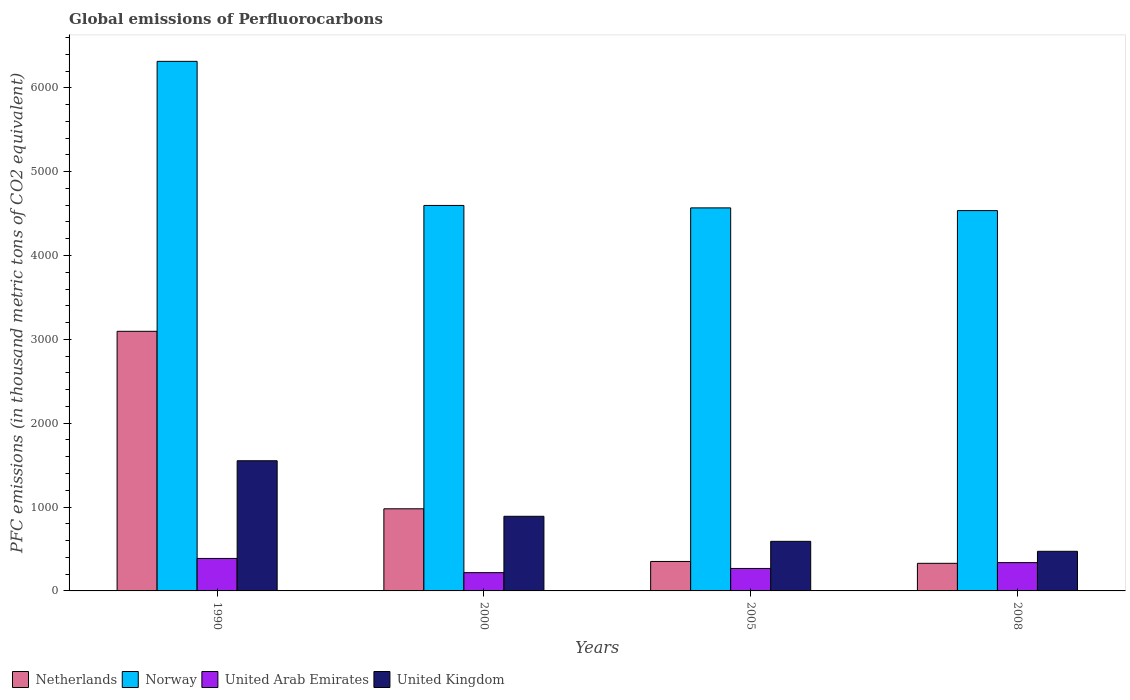How many groups of bars are there?
Offer a very short reply. 4. Are the number of bars on each tick of the X-axis equal?
Offer a very short reply. Yes. In how many cases, is the number of bars for a given year not equal to the number of legend labels?
Your answer should be compact. 0. What is the global emissions of Perfluorocarbons in United Kingdom in 1990?
Your answer should be very brief. 1552.5. Across all years, what is the maximum global emissions of Perfluorocarbons in Netherlands?
Offer a terse response. 3096.2. Across all years, what is the minimum global emissions of Perfluorocarbons in United Arab Emirates?
Offer a very short reply. 218. In which year was the global emissions of Perfluorocarbons in United Kingdom maximum?
Give a very brief answer. 1990. What is the total global emissions of Perfluorocarbons in United Arab Emirates in the graph?
Your answer should be compact. 1210.8. What is the difference between the global emissions of Perfluorocarbons in Netherlands in 2005 and that in 2008?
Offer a very short reply. 22.2. What is the difference between the global emissions of Perfluorocarbons in Netherlands in 2008 and the global emissions of Perfluorocarbons in United Arab Emirates in 1990?
Offer a terse response. -58.1. What is the average global emissions of Perfluorocarbons in United Kingdom per year?
Your answer should be very brief. 876.6. In the year 2008, what is the difference between the global emissions of Perfluorocarbons in United Kingdom and global emissions of Perfluorocarbons in United Arab Emirates?
Offer a terse response. 134.8. What is the ratio of the global emissions of Perfluorocarbons in Norway in 1990 to that in 2008?
Provide a succinct answer. 1.39. Is the difference between the global emissions of Perfluorocarbons in United Kingdom in 2000 and 2005 greater than the difference between the global emissions of Perfluorocarbons in United Arab Emirates in 2000 and 2005?
Your answer should be very brief. Yes. What is the difference between the highest and the second highest global emissions of Perfluorocarbons in United Arab Emirates?
Your answer should be very brief. 49.7. What is the difference between the highest and the lowest global emissions of Perfluorocarbons in Netherlands?
Ensure brevity in your answer.  2767. In how many years, is the global emissions of Perfluorocarbons in United Arab Emirates greater than the average global emissions of Perfluorocarbons in United Arab Emirates taken over all years?
Ensure brevity in your answer.  2. Is it the case that in every year, the sum of the global emissions of Perfluorocarbons in United Arab Emirates and global emissions of Perfluorocarbons in Netherlands is greater than the sum of global emissions of Perfluorocarbons in Norway and global emissions of Perfluorocarbons in United Kingdom?
Your response must be concise. Yes. What does the 4th bar from the left in 1990 represents?
Your answer should be compact. United Kingdom. Is it the case that in every year, the sum of the global emissions of Perfluorocarbons in United Arab Emirates and global emissions of Perfluorocarbons in Netherlands is greater than the global emissions of Perfluorocarbons in United Kingdom?
Provide a succinct answer. Yes. How many bars are there?
Your answer should be compact. 16. Are all the bars in the graph horizontal?
Offer a very short reply. No. How many years are there in the graph?
Provide a succinct answer. 4. Are the values on the major ticks of Y-axis written in scientific E-notation?
Ensure brevity in your answer.  No. What is the title of the graph?
Offer a very short reply. Global emissions of Perfluorocarbons. What is the label or title of the Y-axis?
Give a very brief answer. PFC emissions (in thousand metric tons of CO2 equivalent). What is the PFC emissions (in thousand metric tons of CO2 equivalent) in Netherlands in 1990?
Your response must be concise. 3096.2. What is the PFC emissions (in thousand metric tons of CO2 equivalent) in Norway in 1990?
Offer a very short reply. 6315.7. What is the PFC emissions (in thousand metric tons of CO2 equivalent) of United Arab Emirates in 1990?
Provide a short and direct response. 387.3. What is the PFC emissions (in thousand metric tons of CO2 equivalent) in United Kingdom in 1990?
Offer a terse response. 1552.5. What is the PFC emissions (in thousand metric tons of CO2 equivalent) of Netherlands in 2000?
Your response must be concise. 979.5. What is the PFC emissions (in thousand metric tons of CO2 equivalent) in Norway in 2000?
Ensure brevity in your answer.  4597.3. What is the PFC emissions (in thousand metric tons of CO2 equivalent) in United Arab Emirates in 2000?
Offer a terse response. 218. What is the PFC emissions (in thousand metric tons of CO2 equivalent) in United Kingdom in 2000?
Your answer should be compact. 890.1. What is the PFC emissions (in thousand metric tons of CO2 equivalent) in Netherlands in 2005?
Your answer should be very brief. 351.4. What is the PFC emissions (in thousand metric tons of CO2 equivalent) of Norway in 2005?
Offer a very short reply. 4568.1. What is the PFC emissions (in thousand metric tons of CO2 equivalent) in United Arab Emirates in 2005?
Provide a succinct answer. 267.9. What is the PFC emissions (in thousand metric tons of CO2 equivalent) in United Kingdom in 2005?
Provide a short and direct response. 591.4. What is the PFC emissions (in thousand metric tons of CO2 equivalent) of Netherlands in 2008?
Provide a succinct answer. 329.2. What is the PFC emissions (in thousand metric tons of CO2 equivalent) of Norway in 2008?
Provide a short and direct response. 4535.7. What is the PFC emissions (in thousand metric tons of CO2 equivalent) of United Arab Emirates in 2008?
Provide a succinct answer. 337.6. What is the PFC emissions (in thousand metric tons of CO2 equivalent) of United Kingdom in 2008?
Keep it short and to the point. 472.4. Across all years, what is the maximum PFC emissions (in thousand metric tons of CO2 equivalent) in Netherlands?
Offer a terse response. 3096.2. Across all years, what is the maximum PFC emissions (in thousand metric tons of CO2 equivalent) of Norway?
Your answer should be very brief. 6315.7. Across all years, what is the maximum PFC emissions (in thousand metric tons of CO2 equivalent) of United Arab Emirates?
Your response must be concise. 387.3. Across all years, what is the maximum PFC emissions (in thousand metric tons of CO2 equivalent) of United Kingdom?
Provide a short and direct response. 1552.5. Across all years, what is the minimum PFC emissions (in thousand metric tons of CO2 equivalent) of Netherlands?
Keep it short and to the point. 329.2. Across all years, what is the minimum PFC emissions (in thousand metric tons of CO2 equivalent) of Norway?
Make the answer very short. 4535.7. Across all years, what is the minimum PFC emissions (in thousand metric tons of CO2 equivalent) of United Arab Emirates?
Your answer should be compact. 218. Across all years, what is the minimum PFC emissions (in thousand metric tons of CO2 equivalent) in United Kingdom?
Offer a terse response. 472.4. What is the total PFC emissions (in thousand metric tons of CO2 equivalent) of Netherlands in the graph?
Provide a short and direct response. 4756.3. What is the total PFC emissions (in thousand metric tons of CO2 equivalent) of Norway in the graph?
Give a very brief answer. 2.00e+04. What is the total PFC emissions (in thousand metric tons of CO2 equivalent) in United Arab Emirates in the graph?
Offer a very short reply. 1210.8. What is the total PFC emissions (in thousand metric tons of CO2 equivalent) in United Kingdom in the graph?
Offer a very short reply. 3506.4. What is the difference between the PFC emissions (in thousand metric tons of CO2 equivalent) in Netherlands in 1990 and that in 2000?
Provide a succinct answer. 2116.7. What is the difference between the PFC emissions (in thousand metric tons of CO2 equivalent) of Norway in 1990 and that in 2000?
Keep it short and to the point. 1718.4. What is the difference between the PFC emissions (in thousand metric tons of CO2 equivalent) of United Arab Emirates in 1990 and that in 2000?
Your answer should be very brief. 169.3. What is the difference between the PFC emissions (in thousand metric tons of CO2 equivalent) in United Kingdom in 1990 and that in 2000?
Keep it short and to the point. 662.4. What is the difference between the PFC emissions (in thousand metric tons of CO2 equivalent) in Netherlands in 1990 and that in 2005?
Offer a terse response. 2744.8. What is the difference between the PFC emissions (in thousand metric tons of CO2 equivalent) of Norway in 1990 and that in 2005?
Provide a succinct answer. 1747.6. What is the difference between the PFC emissions (in thousand metric tons of CO2 equivalent) of United Arab Emirates in 1990 and that in 2005?
Keep it short and to the point. 119.4. What is the difference between the PFC emissions (in thousand metric tons of CO2 equivalent) of United Kingdom in 1990 and that in 2005?
Give a very brief answer. 961.1. What is the difference between the PFC emissions (in thousand metric tons of CO2 equivalent) in Netherlands in 1990 and that in 2008?
Ensure brevity in your answer.  2767. What is the difference between the PFC emissions (in thousand metric tons of CO2 equivalent) of Norway in 1990 and that in 2008?
Offer a terse response. 1780. What is the difference between the PFC emissions (in thousand metric tons of CO2 equivalent) in United Arab Emirates in 1990 and that in 2008?
Your answer should be very brief. 49.7. What is the difference between the PFC emissions (in thousand metric tons of CO2 equivalent) of United Kingdom in 1990 and that in 2008?
Your response must be concise. 1080.1. What is the difference between the PFC emissions (in thousand metric tons of CO2 equivalent) in Netherlands in 2000 and that in 2005?
Offer a terse response. 628.1. What is the difference between the PFC emissions (in thousand metric tons of CO2 equivalent) of Norway in 2000 and that in 2005?
Ensure brevity in your answer.  29.2. What is the difference between the PFC emissions (in thousand metric tons of CO2 equivalent) of United Arab Emirates in 2000 and that in 2005?
Provide a short and direct response. -49.9. What is the difference between the PFC emissions (in thousand metric tons of CO2 equivalent) in United Kingdom in 2000 and that in 2005?
Offer a terse response. 298.7. What is the difference between the PFC emissions (in thousand metric tons of CO2 equivalent) in Netherlands in 2000 and that in 2008?
Make the answer very short. 650.3. What is the difference between the PFC emissions (in thousand metric tons of CO2 equivalent) in Norway in 2000 and that in 2008?
Your answer should be compact. 61.6. What is the difference between the PFC emissions (in thousand metric tons of CO2 equivalent) in United Arab Emirates in 2000 and that in 2008?
Your response must be concise. -119.6. What is the difference between the PFC emissions (in thousand metric tons of CO2 equivalent) in United Kingdom in 2000 and that in 2008?
Offer a terse response. 417.7. What is the difference between the PFC emissions (in thousand metric tons of CO2 equivalent) in Netherlands in 2005 and that in 2008?
Provide a succinct answer. 22.2. What is the difference between the PFC emissions (in thousand metric tons of CO2 equivalent) in Norway in 2005 and that in 2008?
Ensure brevity in your answer.  32.4. What is the difference between the PFC emissions (in thousand metric tons of CO2 equivalent) in United Arab Emirates in 2005 and that in 2008?
Provide a short and direct response. -69.7. What is the difference between the PFC emissions (in thousand metric tons of CO2 equivalent) in United Kingdom in 2005 and that in 2008?
Keep it short and to the point. 119. What is the difference between the PFC emissions (in thousand metric tons of CO2 equivalent) in Netherlands in 1990 and the PFC emissions (in thousand metric tons of CO2 equivalent) in Norway in 2000?
Your answer should be compact. -1501.1. What is the difference between the PFC emissions (in thousand metric tons of CO2 equivalent) in Netherlands in 1990 and the PFC emissions (in thousand metric tons of CO2 equivalent) in United Arab Emirates in 2000?
Offer a terse response. 2878.2. What is the difference between the PFC emissions (in thousand metric tons of CO2 equivalent) in Netherlands in 1990 and the PFC emissions (in thousand metric tons of CO2 equivalent) in United Kingdom in 2000?
Make the answer very short. 2206.1. What is the difference between the PFC emissions (in thousand metric tons of CO2 equivalent) in Norway in 1990 and the PFC emissions (in thousand metric tons of CO2 equivalent) in United Arab Emirates in 2000?
Your response must be concise. 6097.7. What is the difference between the PFC emissions (in thousand metric tons of CO2 equivalent) in Norway in 1990 and the PFC emissions (in thousand metric tons of CO2 equivalent) in United Kingdom in 2000?
Your response must be concise. 5425.6. What is the difference between the PFC emissions (in thousand metric tons of CO2 equivalent) in United Arab Emirates in 1990 and the PFC emissions (in thousand metric tons of CO2 equivalent) in United Kingdom in 2000?
Provide a succinct answer. -502.8. What is the difference between the PFC emissions (in thousand metric tons of CO2 equivalent) of Netherlands in 1990 and the PFC emissions (in thousand metric tons of CO2 equivalent) of Norway in 2005?
Give a very brief answer. -1471.9. What is the difference between the PFC emissions (in thousand metric tons of CO2 equivalent) in Netherlands in 1990 and the PFC emissions (in thousand metric tons of CO2 equivalent) in United Arab Emirates in 2005?
Your answer should be very brief. 2828.3. What is the difference between the PFC emissions (in thousand metric tons of CO2 equivalent) in Netherlands in 1990 and the PFC emissions (in thousand metric tons of CO2 equivalent) in United Kingdom in 2005?
Your response must be concise. 2504.8. What is the difference between the PFC emissions (in thousand metric tons of CO2 equivalent) in Norway in 1990 and the PFC emissions (in thousand metric tons of CO2 equivalent) in United Arab Emirates in 2005?
Ensure brevity in your answer.  6047.8. What is the difference between the PFC emissions (in thousand metric tons of CO2 equivalent) of Norway in 1990 and the PFC emissions (in thousand metric tons of CO2 equivalent) of United Kingdom in 2005?
Your answer should be compact. 5724.3. What is the difference between the PFC emissions (in thousand metric tons of CO2 equivalent) of United Arab Emirates in 1990 and the PFC emissions (in thousand metric tons of CO2 equivalent) of United Kingdom in 2005?
Your answer should be compact. -204.1. What is the difference between the PFC emissions (in thousand metric tons of CO2 equivalent) in Netherlands in 1990 and the PFC emissions (in thousand metric tons of CO2 equivalent) in Norway in 2008?
Your answer should be very brief. -1439.5. What is the difference between the PFC emissions (in thousand metric tons of CO2 equivalent) of Netherlands in 1990 and the PFC emissions (in thousand metric tons of CO2 equivalent) of United Arab Emirates in 2008?
Offer a very short reply. 2758.6. What is the difference between the PFC emissions (in thousand metric tons of CO2 equivalent) in Netherlands in 1990 and the PFC emissions (in thousand metric tons of CO2 equivalent) in United Kingdom in 2008?
Provide a short and direct response. 2623.8. What is the difference between the PFC emissions (in thousand metric tons of CO2 equivalent) of Norway in 1990 and the PFC emissions (in thousand metric tons of CO2 equivalent) of United Arab Emirates in 2008?
Offer a terse response. 5978.1. What is the difference between the PFC emissions (in thousand metric tons of CO2 equivalent) of Norway in 1990 and the PFC emissions (in thousand metric tons of CO2 equivalent) of United Kingdom in 2008?
Give a very brief answer. 5843.3. What is the difference between the PFC emissions (in thousand metric tons of CO2 equivalent) of United Arab Emirates in 1990 and the PFC emissions (in thousand metric tons of CO2 equivalent) of United Kingdom in 2008?
Offer a very short reply. -85.1. What is the difference between the PFC emissions (in thousand metric tons of CO2 equivalent) in Netherlands in 2000 and the PFC emissions (in thousand metric tons of CO2 equivalent) in Norway in 2005?
Provide a short and direct response. -3588.6. What is the difference between the PFC emissions (in thousand metric tons of CO2 equivalent) in Netherlands in 2000 and the PFC emissions (in thousand metric tons of CO2 equivalent) in United Arab Emirates in 2005?
Provide a short and direct response. 711.6. What is the difference between the PFC emissions (in thousand metric tons of CO2 equivalent) of Netherlands in 2000 and the PFC emissions (in thousand metric tons of CO2 equivalent) of United Kingdom in 2005?
Your answer should be compact. 388.1. What is the difference between the PFC emissions (in thousand metric tons of CO2 equivalent) in Norway in 2000 and the PFC emissions (in thousand metric tons of CO2 equivalent) in United Arab Emirates in 2005?
Offer a terse response. 4329.4. What is the difference between the PFC emissions (in thousand metric tons of CO2 equivalent) in Norway in 2000 and the PFC emissions (in thousand metric tons of CO2 equivalent) in United Kingdom in 2005?
Provide a short and direct response. 4005.9. What is the difference between the PFC emissions (in thousand metric tons of CO2 equivalent) of United Arab Emirates in 2000 and the PFC emissions (in thousand metric tons of CO2 equivalent) of United Kingdom in 2005?
Your response must be concise. -373.4. What is the difference between the PFC emissions (in thousand metric tons of CO2 equivalent) in Netherlands in 2000 and the PFC emissions (in thousand metric tons of CO2 equivalent) in Norway in 2008?
Keep it short and to the point. -3556.2. What is the difference between the PFC emissions (in thousand metric tons of CO2 equivalent) in Netherlands in 2000 and the PFC emissions (in thousand metric tons of CO2 equivalent) in United Arab Emirates in 2008?
Your answer should be compact. 641.9. What is the difference between the PFC emissions (in thousand metric tons of CO2 equivalent) of Netherlands in 2000 and the PFC emissions (in thousand metric tons of CO2 equivalent) of United Kingdom in 2008?
Provide a short and direct response. 507.1. What is the difference between the PFC emissions (in thousand metric tons of CO2 equivalent) in Norway in 2000 and the PFC emissions (in thousand metric tons of CO2 equivalent) in United Arab Emirates in 2008?
Keep it short and to the point. 4259.7. What is the difference between the PFC emissions (in thousand metric tons of CO2 equivalent) of Norway in 2000 and the PFC emissions (in thousand metric tons of CO2 equivalent) of United Kingdom in 2008?
Give a very brief answer. 4124.9. What is the difference between the PFC emissions (in thousand metric tons of CO2 equivalent) in United Arab Emirates in 2000 and the PFC emissions (in thousand metric tons of CO2 equivalent) in United Kingdom in 2008?
Offer a terse response. -254.4. What is the difference between the PFC emissions (in thousand metric tons of CO2 equivalent) in Netherlands in 2005 and the PFC emissions (in thousand metric tons of CO2 equivalent) in Norway in 2008?
Provide a short and direct response. -4184.3. What is the difference between the PFC emissions (in thousand metric tons of CO2 equivalent) in Netherlands in 2005 and the PFC emissions (in thousand metric tons of CO2 equivalent) in United Kingdom in 2008?
Provide a short and direct response. -121. What is the difference between the PFC emissions (in thousand metric tons of CO2 equivalent) in Norway in 2005 and the PFC emissions (in thousand metric tons of CO2 equivalent) in United Arab Emirates in 2008?
Your answer should be compact. 4230.5. What is the difference between the PFC emissions (in thousand metric tons of CO2 equivalent) in Norway in 2005 and the PFC emissions (in thousand metric tons of CO2 equivalent) in United Kingdom in 2008?
Ensure brevity in your answer.  4095.7. What is the difference between the PFC emissions (in thousand metric tons of CO2 equivalent) of United Arab Emirates in 2005 and the PFC emissions (in thousand metric tons of CO2 equivalent) of United Kingdom in 2008?
Provide a short and direct response. -204.5. What is the average PFC emissions (in thousand metric tons of CO2 equivalent) of Netherlands per year?
Give a very brief answer. 1189.08. What is the average PFC emissions (in thousand metric tons of CO2 equivalent) in Norway per year?
Ensure brevity in your answer.  5004.2. What is the average PFC emissions (in thousand metric tons of CO2 equivalent) of United Arab Emirates per year?
Provide a succinct answer. 302.7. What is the average PFC emissions (in thousand metric tons of CO2 equivalent) of United Kingdom per year?
Keep it short and to the point. 876.6. In the year 1990, what is the difference between the PFC emissions (in thousand metric tons of CO2 equivalent) in Netherlands and PFC emissions (in thousand metric tons of CO2 equivalent) in Norway?
Keep it short and to the point. -3219.5. In the year 1990, what is the difference between the PFC emissions (in thousand metric tons of CO2 equivalent) in Netherlands and PFC emissions (in thousand metric tons of CO2 equivalent) in United Arab Emirates?
Offer a very short reply. 2708.9. In the year 1990, what is the difference between the PFC emissions (in thousand metric tons of CO2 equivalent) of Netherlands and PFC emissions (in thousand metric tons of CO2 equivalent) of United Kingdom?
Make the answer very short. 1543.7. In the year 1990, what is the difference between the PFC emissions (in thousand metric tons of CO2 equivalent) of Norway and PFC emissions (in thousand metric tons of CO2 equivalent) of United Arab Emirates?
Offer a terse response. 5928.4. In the year 1990, what is the difference between the PFC emissions (in thousand metric tons of CO2 equivalent) of Norway and PFC emissions (in thousand metric tons of CO2 equivalent) of United Kingdom?
Your answer should be very brief. 4763.2. In the year 1990, what is the difference between the PFC emissions (in thousand metric tons of CO2 equivalent) in United Arab Emirates and PFC emissions (in thousand metric tons of CO2 equivalent) in United Kingdom?
Offer a very short reply. -1165.2. In the year 2000, what is the difference between the PFC emissions (in thousand metric tons of CO2 equivalent) of Netherlands and PFC emissions (in thousand metric tons of CO2 equivalent) of Norway?
Offer a terse response. -3617.8. In the year 2000, what is the difference between the PFC emissions (in thousand metric tons of CO2 equivalent) in Netherlands and PFC emissions (in thousand metric tons of CO2 equivalent) in United Arab Emirates?
Make the answer very short. 761.5. In the year 2000, what is the difference between the PFC emissions (in thousand metric tons of CO2 equivalent) in Netherlands and PFC emissions (in thousand metric tons of CO2 equivalent) in United Kingdom?
Offer a very short reply. 89.4. In the year 2000, what is the difference between the PFC emissions (in thousand metric tons of CO2 equivalent) in Norway and PFC emissions (in thousand metric tons of CO2 equivalent) in United Arab Emirates?
Provide a short and direct response. 4379.3. In the year 2000, what is the difference between the PFC emissions (in thousand metric tons of CO2 equivalent) in Norway and PFC emissions (in thousand metric tons of CO2 equivalent) in United Kingdom?
Ensure brevity in your answer.  3707.2. In the year 2000, what is the difference between the PFC emissions (in thousand metric tons of CO2 equivalent) in United Arab Emirates and PFC emissions (in thousand metric tons of CO2 equivalent) in United Kingdom?
Ensure brevity in your answer.  -672.1. In the year 2005, what is the difference between the PFC emissions (in thousand metric tons of CO2 equivalent) of Netherlands and PFC emissions (in thousand metric tons of CO2 equivalent) of Norway?
Provide a succinct answer. -4216.7. In the year 2005, what is the difference between the PFC emissions (in thousand metric tons of CO2 equivalent) in Netherlands and PFC emissions (in thousand metric tons of CO2 equivalent) in United Arab Emirates?
Your response must be concise. 83.5. In the year 2005, what is the difference between the PFC emissions (in thousand metric tons of CO2 equivalent) of Netherlands and PFC emissions (in thousand metric tons of CO2 equivalent) of United Kingdom?
Give a very brief answer. -240. In the year 2005, what is the difference between the PFC emissions (in thousand metric tons of CO2 equivalent) in Norway and PFC emissions (in thousand metric tons of CO2 equivalent) in United Arab Emirates?
Your answer should be compact. 4300.2. In the year 2005, what is the difference between the PFC emissions (in thousand metric tons of CO2 equivalent) in Norway and PFC emissions (in thousand metric tons of CO2 equivalent) in United Kingdom?
Offer a very short reply. 3976.7. In the year 2005, what is the difference between the PFC emissions (in thousand metric tons of CO2 equivalent) of United Arab Emirates and PFC emissions (in thousand metric tons of CO2 equivalent) of United Kingdom?
Make the answer very short. -323.5. In the year 2008, what is the difference between the PFC emissions (in thousand metric tons of CO2 equivalent) in Netherlands and PFC emissions (in thousand metric tons of CO2 equivalent) in Norway?
Offer a very short reply. -4206.5. In the year 2008, what is the difference between the PFC emissions (in thousand metric tons of CO2 equivalent) of Netherlands and PFC emissions (in thousand metric tons of CO2 equivalent) of United Kingdom?
Make the answer very short. -143.2. In the year 2008, what is the difference between the PFC emissions (in thousand metric tons of CO2 equivalent) of Norway and PFC emissions (in thousand metric tons of CO2 equivalent) of United Arab Emirates?
Keep it short and to the point. 4198.1. In the year 2008, what is the difference between the PFC emissions (in thousand metric tons of CO2 equivalent) in Norway and PFC emissions (in thousand metric tons of CO2 equivalent) in United Kingdom?
Give a very brief answer. 4063.3. In the year 2008, what is the difference between the PFC emissions (in thousand metric tons of CO2 equivalent) of United Arab Emirates and PFC emissions (in thousand metric tons of CO2 equivalent) of United Kingdom?
Your response must be concise. -134.8. What is the ratio of the PFC emissions (in thousand metric tons of CO2 equivalent) in Netherlands in 1990 to that in 2000?
Provide a succinct answer. 3.16. What is the ratio of the PFC emissions (in thousand metric tons of CO2 equivalent) of Norway in 1990 to that in 2000?
Offer a terse response. 1.37. What is the ratio of the PFC emissions (in thousand metric tons of CO2 equivalent) in United Arab Emirates in 1990 to that in 2000?
Your answer should be compact. 1.78. What is the ratio of the PFC emissions (in thousand metric tons of CO2 equivalent) of United Kingdom in 1990 to that in 2000?
Make the answer very short. 1.74. What is the ratio of the PFC emissions (in thousand metric tons of CO2 equivalent) of Netherlands in 1990 to that in 2005?
Provide a short and direct response. 8.81. What is the ratio of the PFC emissions (in thousand metric tons of CO2 equivalent) of Norway in 1990 to that in 2005?
Offer a very short reply. 1.38. What is the ratio of the PFC emissions (in thousand metric tons of CO2 equivalent) in United Arab Emirates in 1990 to that in 2005?
Offer a terse response. 1.45. What is the ratio of the PFC emissions (in thousand metric tons of CO2 equivalent) in United Kingdom in 1990 to that in 2005?
Provide a short and direct response. 2.63. What is the ratio of the PFC emissions (in thousand metric tons of CO2 equivalent) in Netherlands in 1990 to that in 2008?
Ensure brevity in your answer.  9.41. What is the ratio of the PFC emissions (in thousand metric tons of CO2 equivalent) in Norway in 1990 to that in 2008?
Make the answer very short. 1.39. What is the ratio of the PFC emissions (in thousand metric tons of CO2 equivalent) in United Arab Emirates in 1990 to that in 2008?
Your response must be concise. 1.15. What is the ratio of the PFC emissions (in thousand metric tons of CO2 equivalent) in United Kingdom in 1990 to that in 2008?
Keep it short and to the point. 3.29. What is the ratio of the PFC emissions (in thousand metric tons of CO2 equivalent) in Netherlands in 2000 to that in 2005?
Offer a very short reply. 2.79. What is the ratio of the PFC emissions (in thousand metric tons of CO2 equivalent) of Norway in 2000 to that in 2005?
Your answer should be very brief. 1.01. What is the ratio of the PFC emissions (in thousand metric tons of CO2 equivalent) of United Arab Emirates in 2000 to that in 2005?
Your answer should be very brief. 0.81. What is the ratio of the PFC emissions (in thousand metric tons of CO2 equivalent) of United Kingdom in 2000 to that in 2005?
Make the answer very short. 1.51. What is the ratio of the PFC emissions (in thousand metric tons of CO2 equivalent) of Netherlands in 2000 to that in 2008?
Your answer should be compact. 2.98. What is the ratio of the PFC emissions (in thousand metric tons of CO2 equivalent) in Norway in 2000 to that in 2008?
Ensure brevity in your answer.  1.01. What is the ratio of the PFC emissions (in thousand metric tons of CO2 equivalent) of United Arab Emirates in 2000 to that in 2008?
Make the answer very short. 0.65. What is the ratio of the PFC emissions (in thousand metric tons of CO2 equivalent) in United Kingdom in 2000 to that in 2008?
Your answer should be compact. 1.88. What is the ratio of the PFC emissions (in thousand metric tons of CO2 equivalent) in Netherlands in 2005 to that in 2008?
Offer a very short reply. 1.07. What is the ratio of the PFC emissions (in thousand metric tons of CO2 equivalent) in Norway in 2005 to that in 2008?
Offer a terse response. 1.01. What is the ratio of the PFC emissions (in thousand metric tons of CO2 equivalent) of United Arab Emirates in 2005 to that in 2008?
Give a very brief answer. 0.79. What is the ratio of the PFC emissions (in thousand metric tons of CO2 equivalent) in United Kingdom in 2005 to that in 2008?
Offer a terse response. 1.25. What is the difference between the highest and the second highest PFC emissions (in thousand metric tons of CO2 equivalent) in Netherlands?
Your response must be concise. 2116.7. What is the difference between the highest and the second highest PFC emissions (in thousand metric tons of CO2 equivalent) in Norway?
Provide a succinct answer. 1718.4. What is the difference between the highest and the second highest PFC emissions (in thousand metric tons of CO2 equivalent) of United Arab Emirates?
Your answer should be very brief. 49.7. What is the difference between the highest and the second highest PFC emissions (in thousand metric tons of CO2 equivalent) in United Kingdom?
Provide a succinct answer. 662.4. What is the difference between the highest and the lowest PFC emissions (in thousand metric tons of CO2 equivalent) of Netherlands?
Your answer should be very brief. 2767. What is the difference between the highest and the lowest PFC emissions (in thousand metric tons of CO2 equivalent) in Norway?
Give a very brief answer. 1780. What is the difference between the highest and the lowest PFC emissions (in thousand metric tons of CO2 equivalent) in United Arab Emirates?
Your answer should be compact. 169.3. What is the difference between the highest and the lowest PFC emissions (in thousand metric tons of CO2 equivalent) of United Kingdom?
Offer a terse response. 1080.1. 